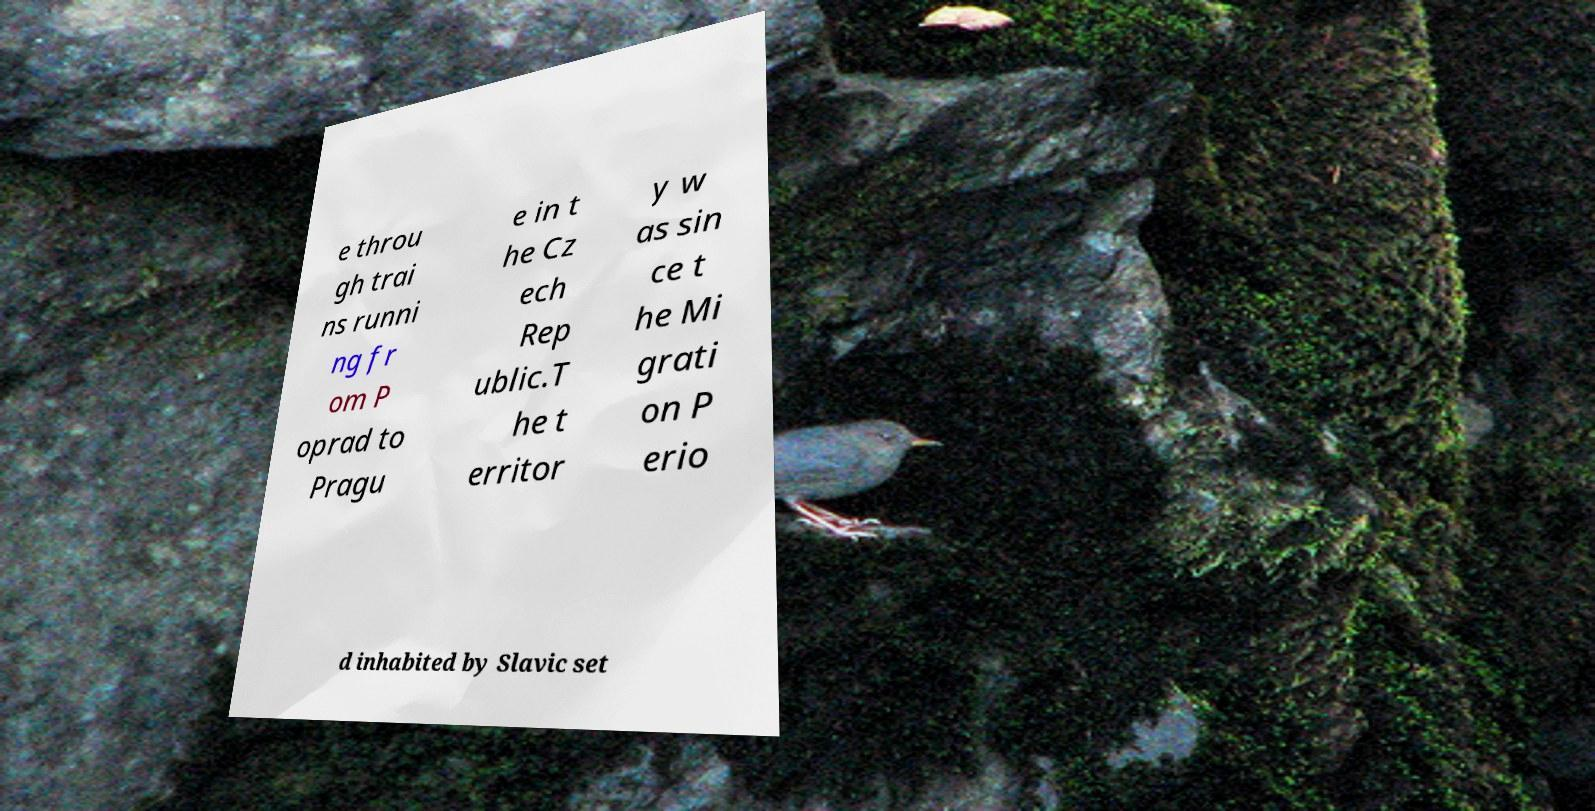Could you extract and type out the text from this image? e throu gh trai ns runni ng fr om P oprad to Pragu e in t he Cz ech Rep ublic.T he t erritor y w as sin ce t he Mi grati on P erio d inhabited by Slavic set 